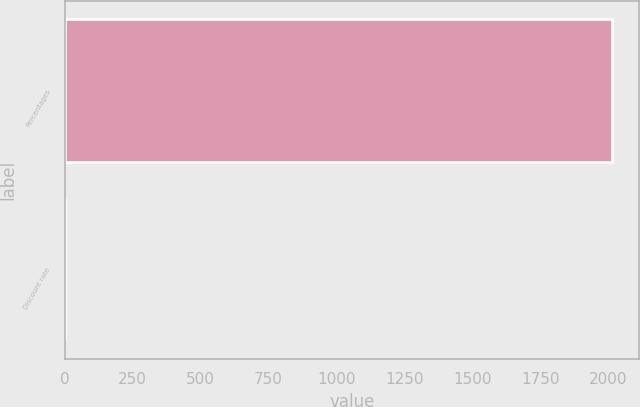<chart> <loc_0><loc_0><loc_500><loc_500><bar_chart><fcel>Percentages<fcel>Discount rate<nl><fcel>2012<fcel>3.48<nl></chart> 